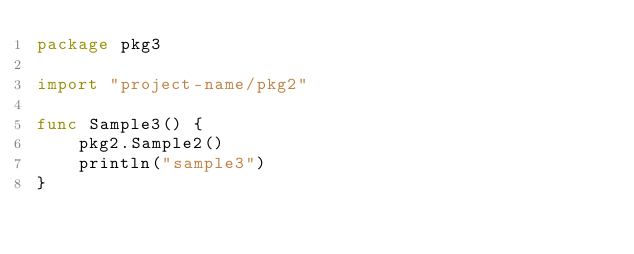<code> <loc_0><loc_0><loc_500><loc_500><_Go_>package pkg3

import "project-name/pkg2"

func Sample3() {
	pkg2.Sample2()
	println("sample3")
}
</code> 